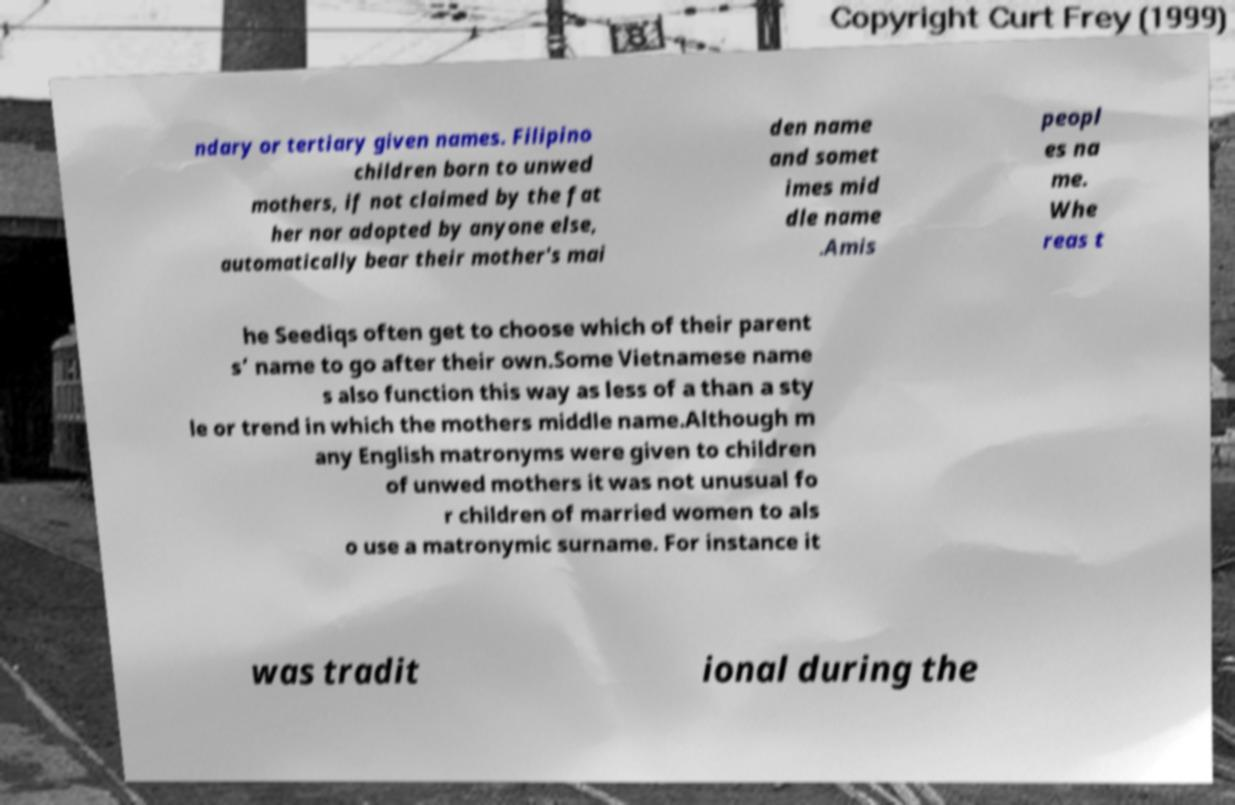What messages or text are displayed in this image? I need them in a readable, typed format. ndary or tertiary given names. Filipino children born to unwed mothers, if not claimed by the fat her nor adopted by anyone else, automatically bear their mother's mai den name and somet imes mid dle name .Amis peopl es na me. Whe reas t he Seediqs often get to choose which of their parent s’ name to go after their own.Some Vietnamese name s also function this way as less of a than a sty le or trend in which the mothers middle name.Although m any English matronyms were given to children of unwed mothers it was not unusual fo r children of married women to als o use a matronymic surname. For instance it was tradit ional during the 